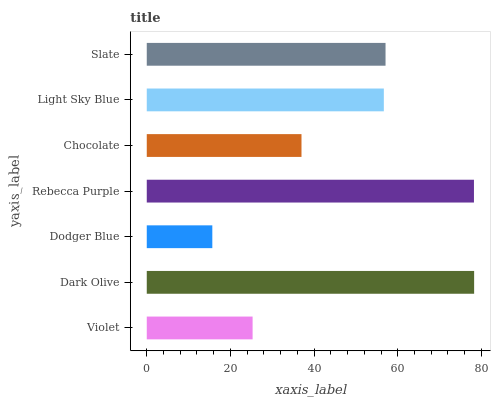Is Dodger Blue the minimum?
Answer yes or no. Yes. Is Dark Olive the maximum?
Answer yes or no. Yes. Is Dark Olive the minimum?
Answer yes or no. No. Is Dodger Blue the maximum?
Answer yes or no. No. Is Dark Olive greater than Dodger Blue?
Answer yes or no. Yes. Is Dodger Blue less than Dark Olive?
Answer yes or no. Yes. Is Dodger Blue greater than Dark Olive?
Answer yes or no. No. Is Dark Olive less than Dodger Blue?
Answer yes or no. No. Is Light Sky Blue the high median?
Answer yes or no. Yes. Is Light Sky Blue the low median?
Answer yes or no. Yes. Is Rebecca Purple the high median?
Answer yes or no. No. Is Dodger Blue the low median?
Answer yes or no. No. 